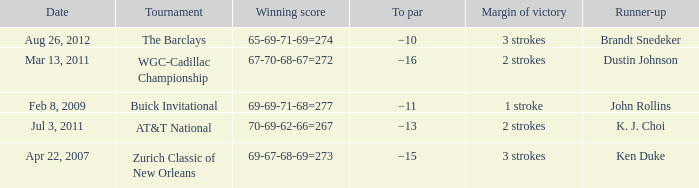Who was the runner-up in the tournament that has a margin of victory of 2 strokes, and a To par of −16? Dustin Johnson. 